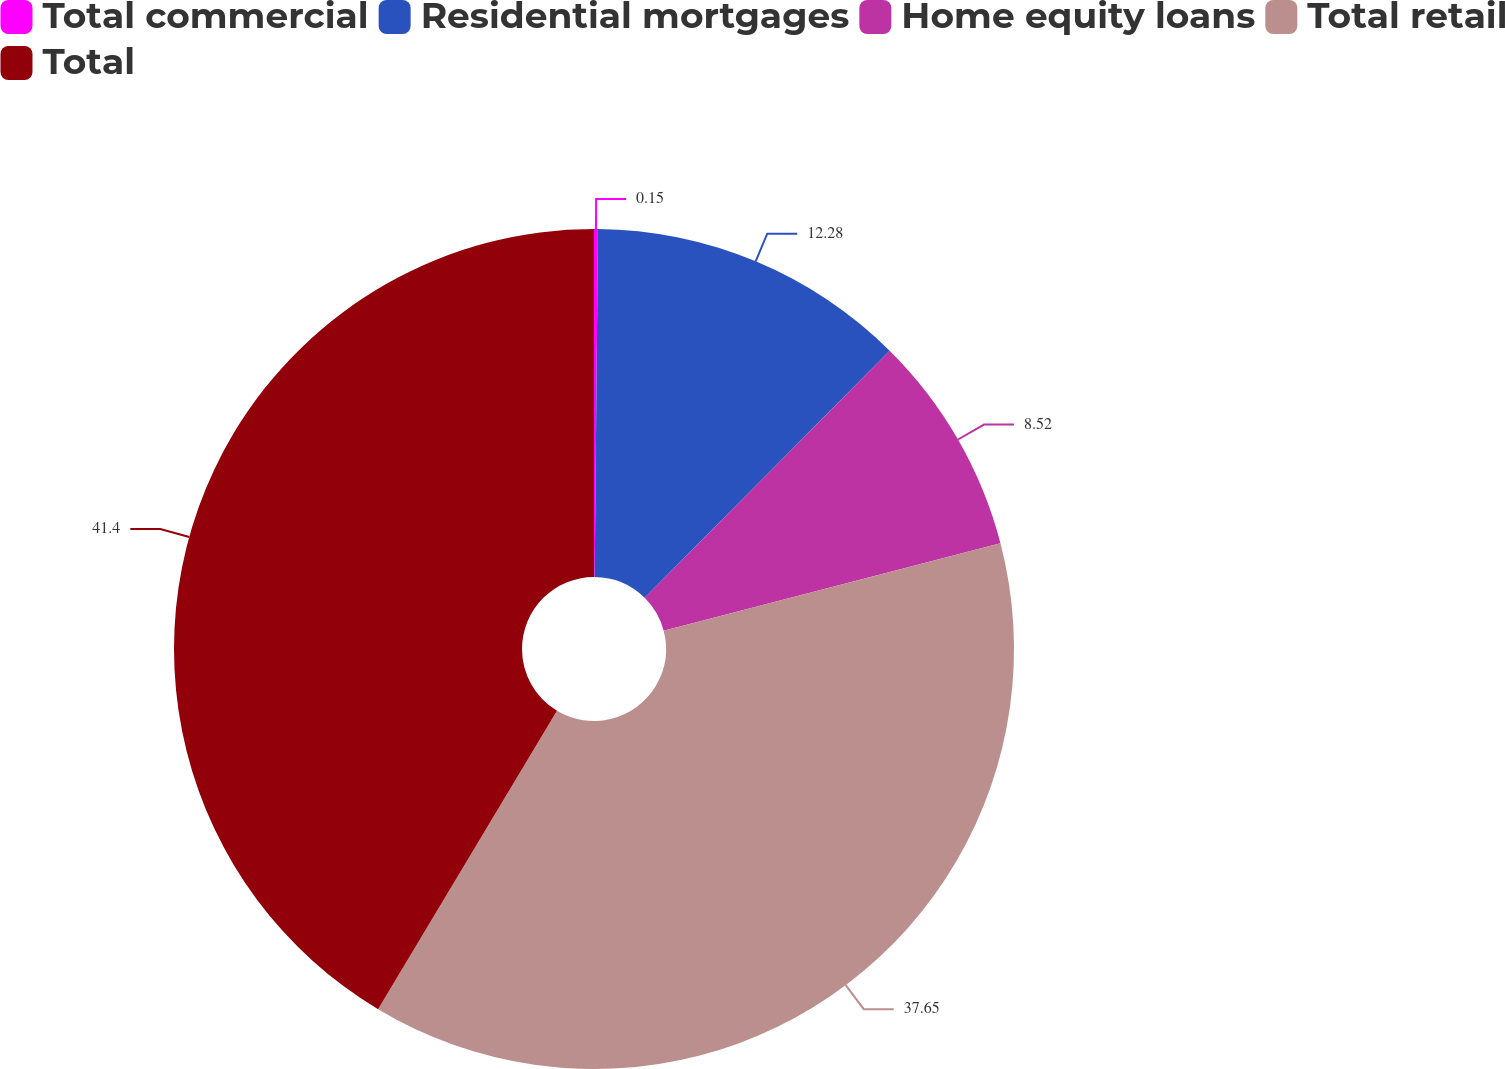Convert chart to OTSL. <chart><loc_0><loc_0><loc_500><loc_500><pie_chart><fcel>Total commercial<fcel>Residential mortgages<fcel>Home equity loans<fcel>Total retail<fcel>Total<nl><fcel>0.15%<fcel>12.28%<fcel>8.52%<fcel>37.65%<fcel>41.41%<nl></chart> 